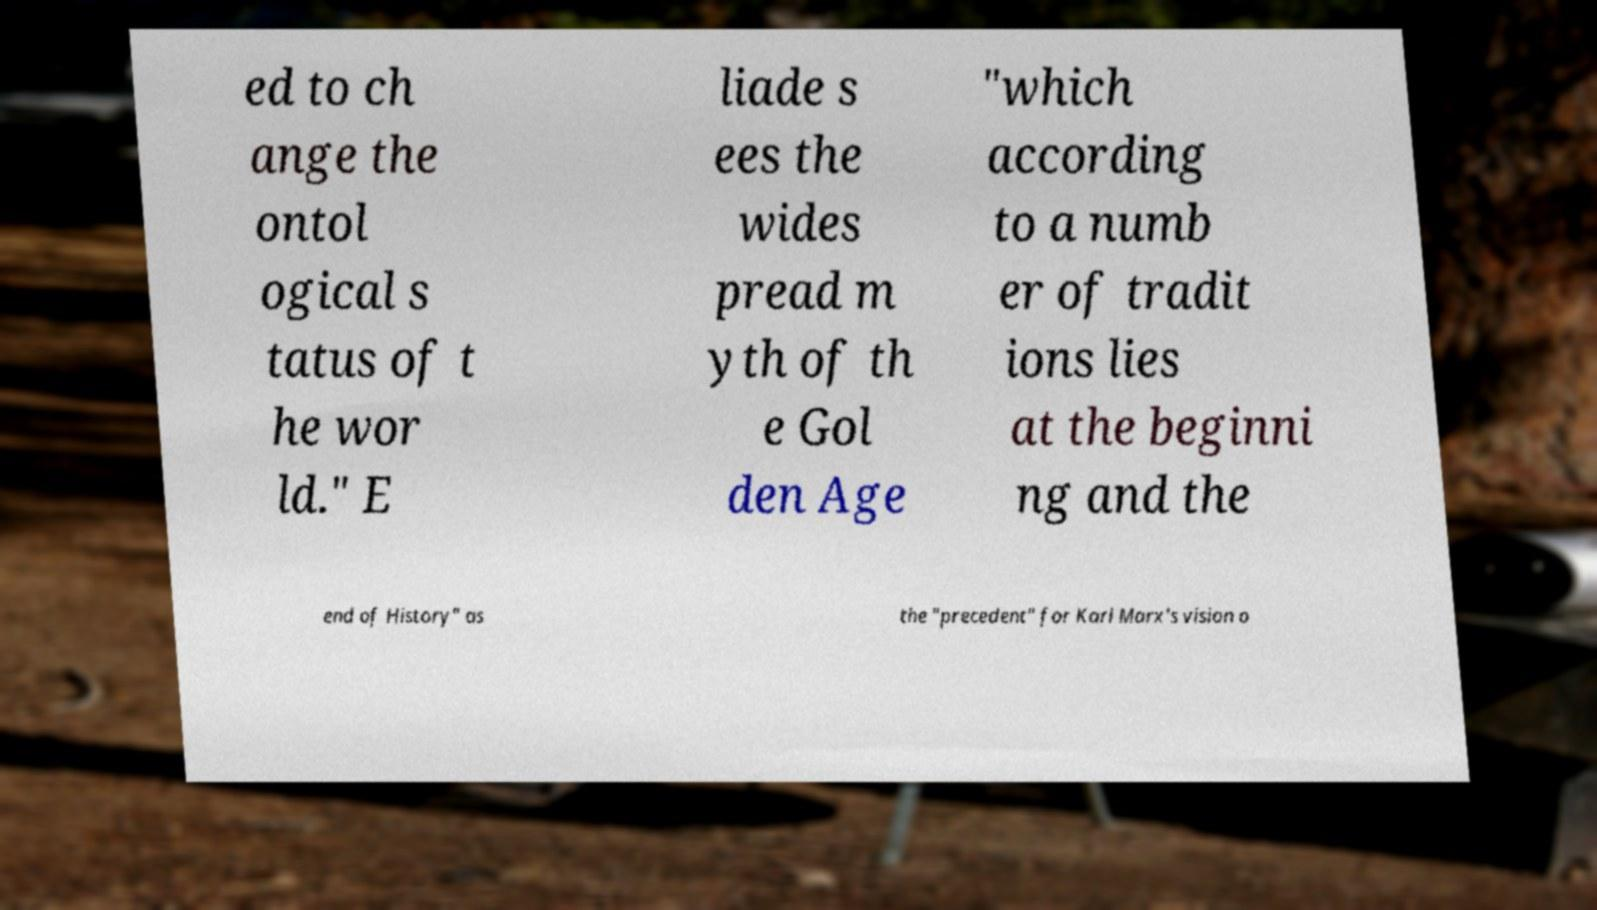Can you accurately transcribe the text from the provided image for me? ed to ch ange the ontol ogical s tatus of t he wor ld." E liade s ees the wides pread m yth of th e Gol den Age "which according to a numb er of tradit ions lies at the beginni ng and the end of History" as the "precedent" for Karl Marx's vision o 